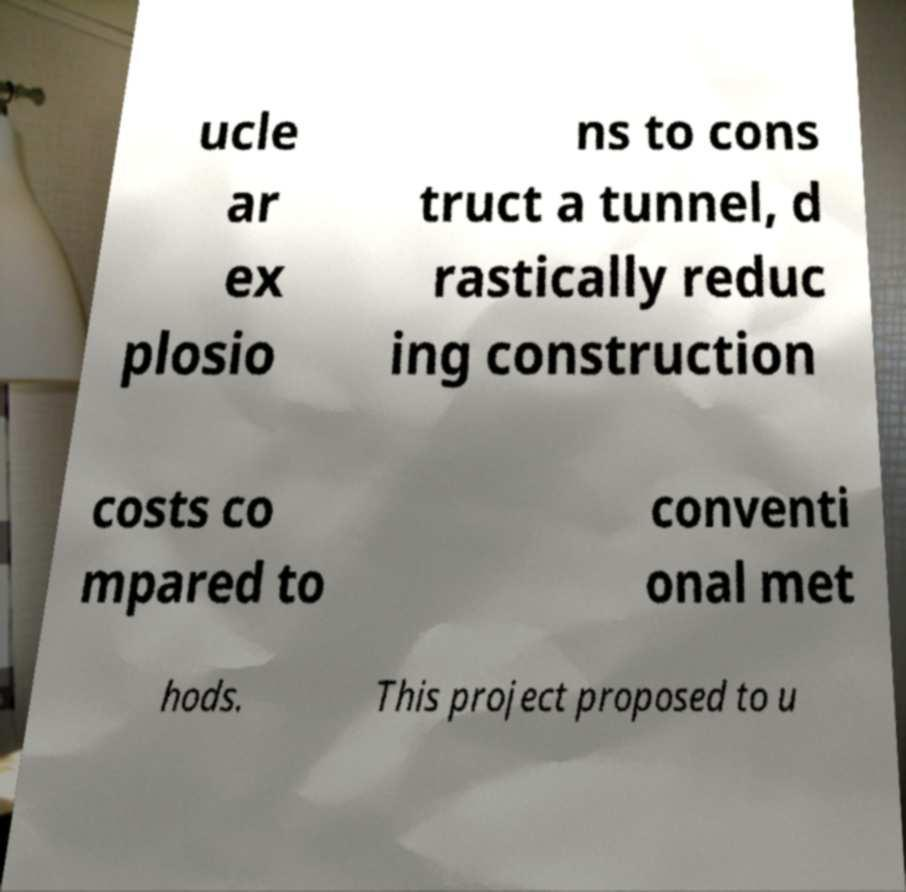Please read and relay the text visible in this image. What does it say? ucle ar ex plosio ns to cons truct a tunnel, d rastically reduc ing construction costs co mpared to conventi onal met hods. This project proposed to u 